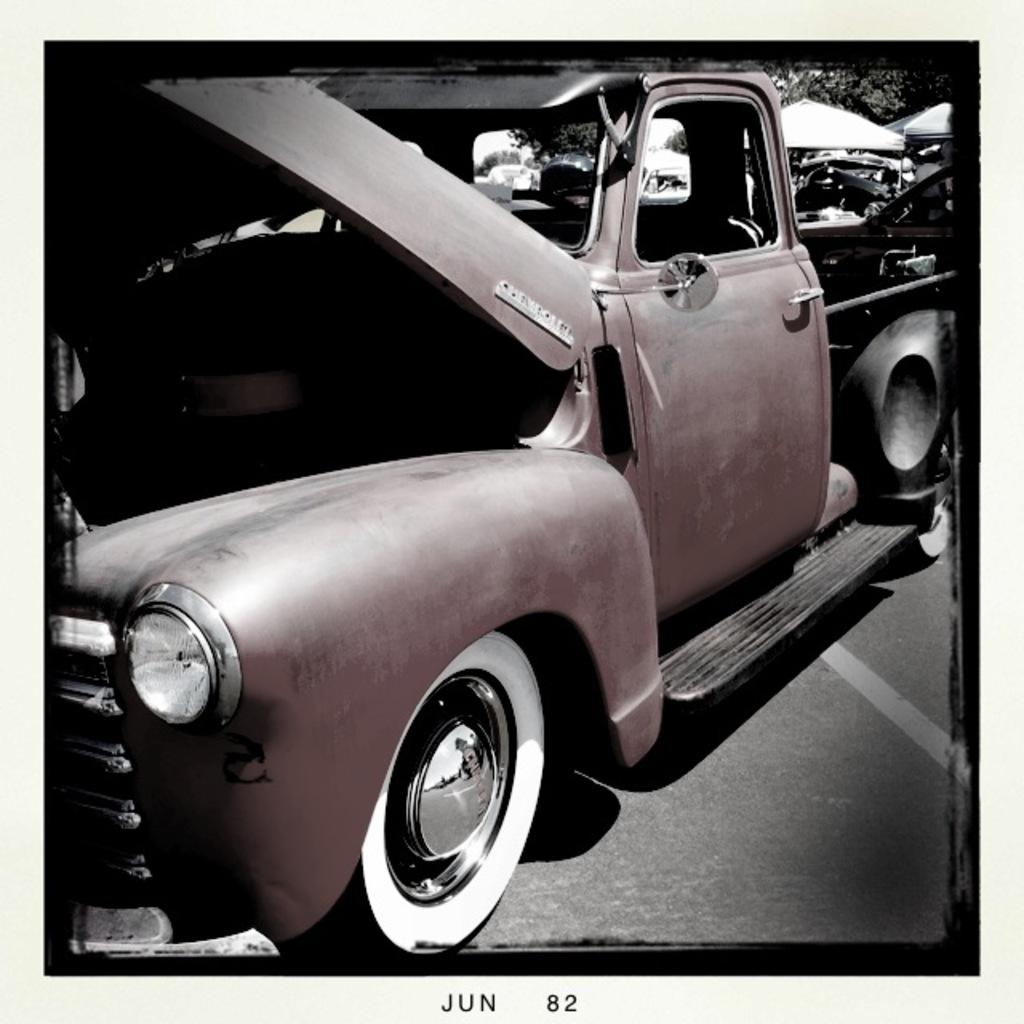What can be seen on the road in the image? There are vehicles on the road in the image. What type of natural scenery is visible in the background of the image? There are trees visible in the background of the image. What is present at the bottom of the image? There is text at the bottom of the image. Can you hear the music playing in the image? There is no mention of music or any sound in the image, so it cannot be heard. How many times does the person in the image sneeze? There is no person present in the image, so it is impossible to determine how many times they sneeze. 